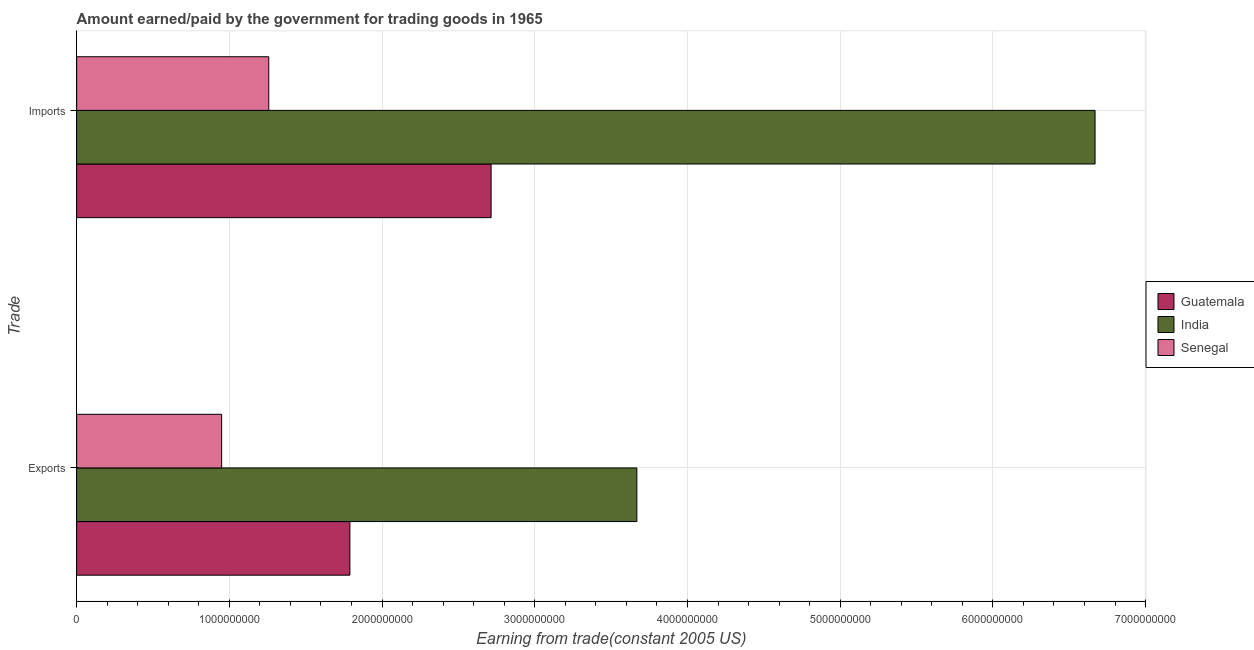How many different coloured bars are there?
Keep it short and to the point. 3. How many groups of bars are there?
Make the answer very short. 2. Are the number of bars on each tick of the Y-axis equal?
Make the answer very short. Yes. How many bars are there on the 2nd tick from the top?
Your answer should be very brief. 3. How many bars are there on the 1st tick from the bottom?
Provide a succinct answer. 3. What is the label of the 2nd group of bars from the top?
Your response must be concise. Exports. What is the amount paid for imports in India?
Offer a terse response. 6.67e+09. Across all countries, what is the maximum amount paid for imports?
Provide a short and direct response. 6.67e+09. Across all countries, what is the minimum amount paid for imports?
Your response must be concise. 1.26e+09. In which country was the amount paid for imports maximum?
Your response must be concise. India. In which country was the amount paid for imports minimum?
Offer a very short reply. Senegal. What is the total amount earned from exports in the graph?
Ensure brevity in your answer.  6.41e+09. What is the difference between the amount earned from exports in Senegal and that in Guatemala?
Keep it short and to the point. -8.40e+08. What is the difference between the amount earned from exports in Senegal and the amount paid for imports in Guatemala?
Make the answer very short. -1.76e+09. What is the average amount earned from exports per country?
Provide a short and direct response. 2.14e+09. What is the difference between the amount earned from exports and amount paid for imports in Senegal?
Provide a short and direct response. -3.09e+08. In how many countries, is the amount paid for imports greater than 4000000000 US$?
Provide a short and direct response. 1. What is the ratio of the amount earned from exports in Guatemala to that in Senegal?
Provide a succinct answer. 1.88. Is the amount paid for imports in Guatemala less than that in India?
Give a very brief answer. Yes. In how many countries, is the amount earned from exports greater than the average amount earned from exports taken over all countries?
Keep it short and to the point. 1. What does the 3rd bar from the top in Imports represents?
Give a very brief answer. Guatemala. What does the 1st bar from the bottom in Exports represents?
Offer a terse response. Guatemala. How many bars are there?
Offer a very short reply. 6. Does the graph contain any zero values?
Your answer should be compact. No. Does the graph contain grids?
Your answer should be compact. Yes. How many legend labels are there?
Your response must be concise. 3. What is the title of the graph?
Make the answer very short. Amount earned/paid by the government for trading goods in 1965. What is the label or title of the X-axis?
Provide a succinct answer. Earning from trade(constant 2005 US). What is the label or title of the Y-axis?
Your answer should be very brief. Trade. What is the Earning from trade(constant 2005 US) of Guatemala in Exports?
Give a very brief answer. 1.79e+09. What is the Earning from trade(constant 2005 US) of India in Exports?
Your answer should be compact. 3.67e+09. What is the Earning from trade(constant 2005 US) of Senegal in Exports?
Your answer should be compact. 9.49e+08. What is the Earning from trade(constant 2005 US) of Guatemala in Imports?
Provide a succinct answer. 2.71e+09. What is the Earning from trade(constant 2005 US) in India in Imports?
Offer a terse response. 6.67e+09. What is the Earning from trade(constant 2005 US) in Senegal in Imports?
Offer a terse response. 1.26e+09. Across all Trade, what is the maximum Earning from trade(constant 2005 US) in Guatemala?
Your answer should be very brief. 2.71e+09. Across all Trade, what is the maximum Earning from trade(constant 2005 US) in India?
Provide a short and direct response. 6.67e+09. Across all Trade, what is the maximum Earning from trade(constant 2005 US) in Senegal?
Offer a very short reply. 1.26e+09. Across all Trade, what is the minimum Earning from trade(constant 2005 US) in Guatemala?
Your response must be concise. 1.79e+09. Across all Trade, what is the minimum Earning from trade(constant 2005 US) of India?
Offer a terse response. 3.67e+09. Across all Trade, what is the minimum Earning from trade(constant 2005 US) of Senegal?
Provide a succinct answer. 9.49e+08. What is the total Earning from trade(constant 2005 US) of Guatemala in the graph?
Give a very brief answer. 4.50e+09. What is the total Earning from trade(constant 2005 US) of India in the graph?
Ensure brevity in your answer.  1.03e+1. What is the total Earning from trade(constant 2005 US) of Senegal in the graph?
Provide a short and direct response. 2.21e+09. What is the difference between the Earning from trade(constant 2005 US) of Guatemala in Exports and that in Imports?
Your answer should be compact. -9.25e+08. What is the difference between the Earning from trade(constant 2005 US) of India in Exports and that in Imports?
Keep it short and to the point. -3.00e+09. What is the difference between the Earning from trade(constant 2005 US) of Senegal in Exports and that in Imports?
Provide a succinct answer. -3.09e+08. What is the difference between the Earning from trade(constant 2005 US) in Guatemala in Exports and the Earning from trade(constant 2005 US) in India in Imports?
Offer a terse response. -4.88e+09. What is the difference between the Earning from trade(constant 2005 US) in Guatemala in Exports and the Earning from trade(constant 2005 US) in Senegal in Imports?
Make the answer very short. 5.31e+08. What is the difference between the Earning from trade(constant 2005 US) of India in Exports and the Earning from trade(constant 2005 US) of Senegal in Imports?
Your response must be concise. 2.41e+09. What is the average Earning from trade(constant 2005 US) in Guatemala per Trade?
Provide a short and direct response. 2.25e+09. What is the average Earning from trade(constant 2005 US) of India per Trade?
Your response must be concise. 5.17e+09. What is the average Earning from trade(constant 2005 US) of Senegal per Trade?
Make the answer very short. 1.10e+09. What is the difference between the Earning from trade(constant 2005 US) of Guatemala and Earning from trade(constant 2005 US) of India in Exports?
Offer a very short reply. -1.88e+09. What is the difference between the Earning from trade(constant 2005 US) of Guatemala and Earning from trade(constant 2005 US) of Senegal in Exports?
Offer a terse response. 8.40e+08. What is the difference between the Earning from trade(constant 2005 US) in India and Earning from trade(constant 2005 US) in Senegal in Exports?
Give a very brief answer. 2.72e+09. What is the difference between the Earning from trade(constant 2005 US) of Guatemala and Earning from trade(constant 2005 US) of India in Imports?
Your answer should be very brief. -3.96e+09. What is the difference between the Earning from trade(constant 2005 US) in Guatemala and Earning from trade(constant 2005 US) in Senegal in Imports?
Provide a short and direct response. 1.46e+09. What is the difference between the Earning from trade(constant 2005 US) of India and Earning from trade(constant 2005 US) of Senegal in Imports?
Give a very brief answer. 5.41e+09. What is the ratio of the Earning from trade(constant 2005 US) of Guatemala in Exports to that in Imports?
Provide a short and direct response. 0.66. What is the ratio of the Earning from trade(constant 2005 US) in India in Exports to that in Imports?
Make the answer very short. 0.55. What is the ratio of the Earning from trade(constant 2005 US) of Senegal in Exports to that in Imports?
Your response must be concise. 0.75. What is the difference between the highest and the second highest Earning from trade(constant 2005 US) of Guatemala?
Give a very brief answer. 9.25e+08. What is the difference between the highest and the second highest Earning from trade(constant 2005 US) of India?
Make the answer very short. 3.00e+09. What is the difference between the highest and the second highest Earning from trade(constant 2005 US) in Senegal?
Provide a short and direct response. 3.09e+08. What is the difference between the highest and the lowest Earning from trade(constant 2005 US) of Guatemala?
Offer a very short reply. 9.25e+08. What is the difference between the highest and the lowest Earning from trade(constant 2005 US) in India?
Ensure brevity in your answer.  3.00e+09. What is the difference between the highest and the lowest Earning from trade(constant 2005 US) in Senegal?
Your response must be concise. 3.09e+08. 